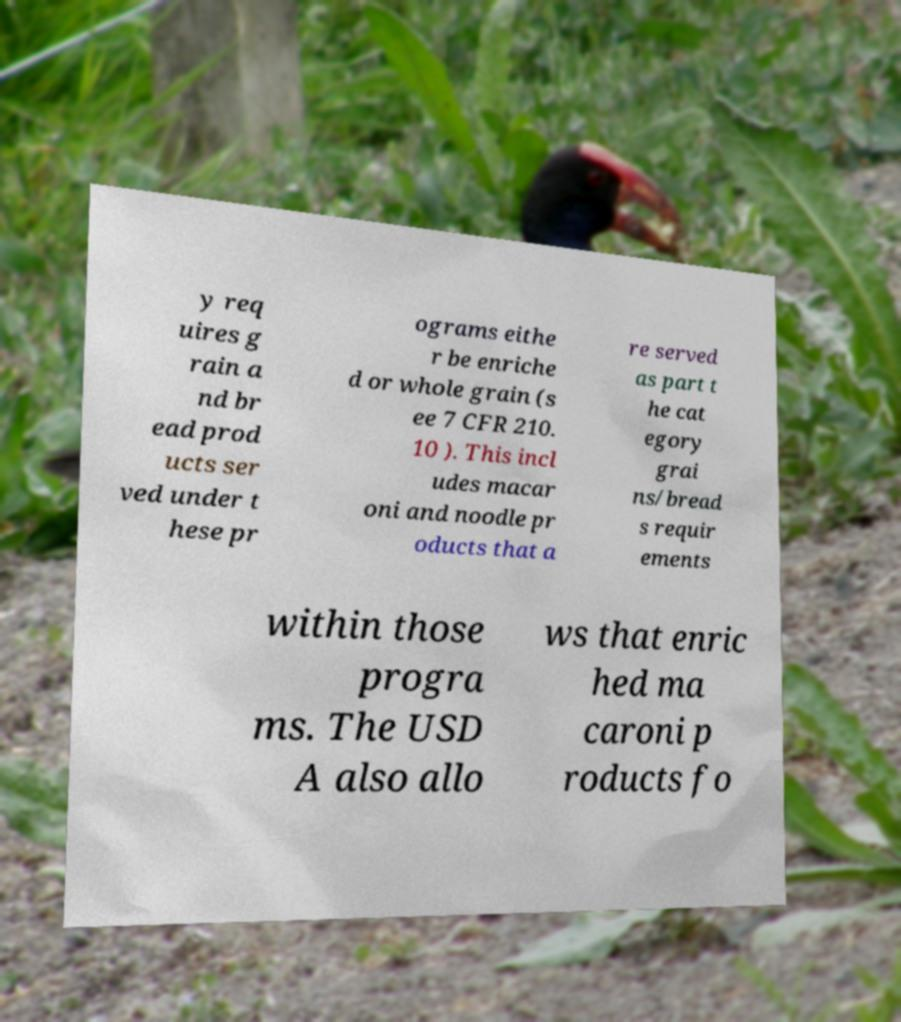Could you extract and type out the text from this image? y req uires g rain a nd br ead prod ucts ser ved under t hese pr ograms eithe r be enriche d or whole grain (s ee 7 CFR 210. 10 ). This incl udes macar oni and noodle pr oducts that a re served as part t he cat egory grai ns/bread s requir ements within those progra ms. The USD A also allo ws that enric hed ma caroni p roducts fo 